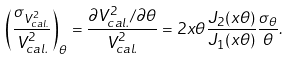<formula> <loc_0><loc_0><loc_500><loc_500>\left ( \frac { \sigma _ { V ^ { 2 } _ { c a l . } } } { V ^ { 2 } _ { c a l . } } \right ) _ { \theta } = \frac { \partial V ^ { 2 } _ { c a l . } / \partial \theta } { V ^ { 2 } _ { c a l . } } = 2 x \theta \frac { J _ { 2 } ( x \theta ) } { J _ { 1 } ( x \theta ) } \frac { \sigma _ { \theta } } { \theta } .</formula> 